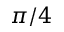<formula> <loc_0><loc_0><loc_500><loc_500>\pi / 4</formula> 